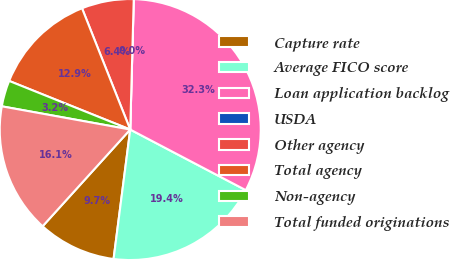Convert chart to OTSL. <chart><loc_0><loc_0><loc_500><loc_500><pie_chart><fcel>Capture rate<fcel>Average FICO score<fcel>Loan application backlog<fcel>USDA<fcel>Other agency<fcel>Total agency<fcel>Non-agency<fcel>Total funded originations<nl><fcel>9.68%<fcel>19.35%<fcel>32.26%<fcel>0.0%<fcel>6.45%<fcel>12.9%<fcel>3.23%<fcel>16.13%<nl></chart> 